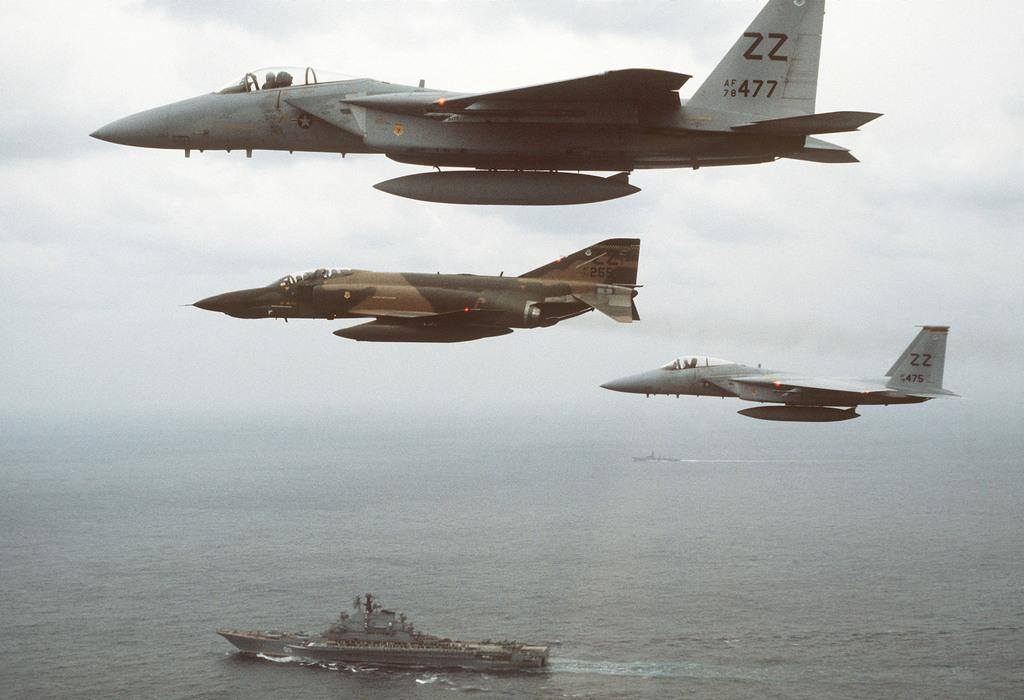What is happening in the sky in the image? There are airplanes flying in the sky. What can be seen in the water in the image? There is a ship in the water. What is the condition of the sky in the image? The sky is cloudy. What type of meat is being served on the bridge in the image? There is no bridge or meat present in the image. How many men are visible on the ship in the image? There is no information about men or the presence of people on the ship in the image. 